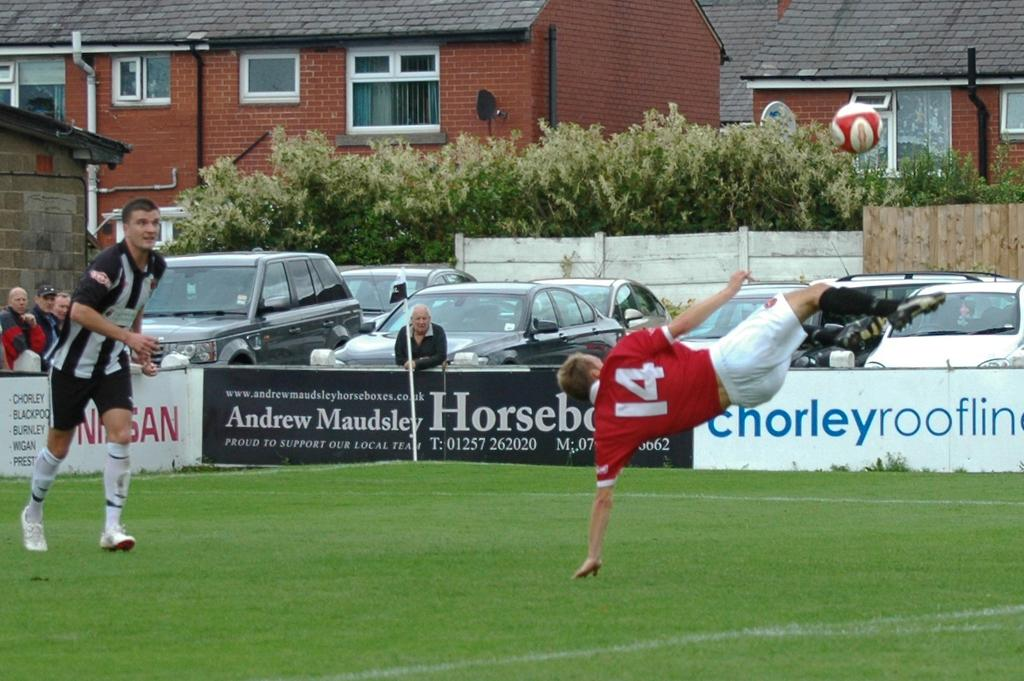<image>
Relay a brief, clear account of the picture shown. a soccer player kicking a ball with jersey number 14 on 